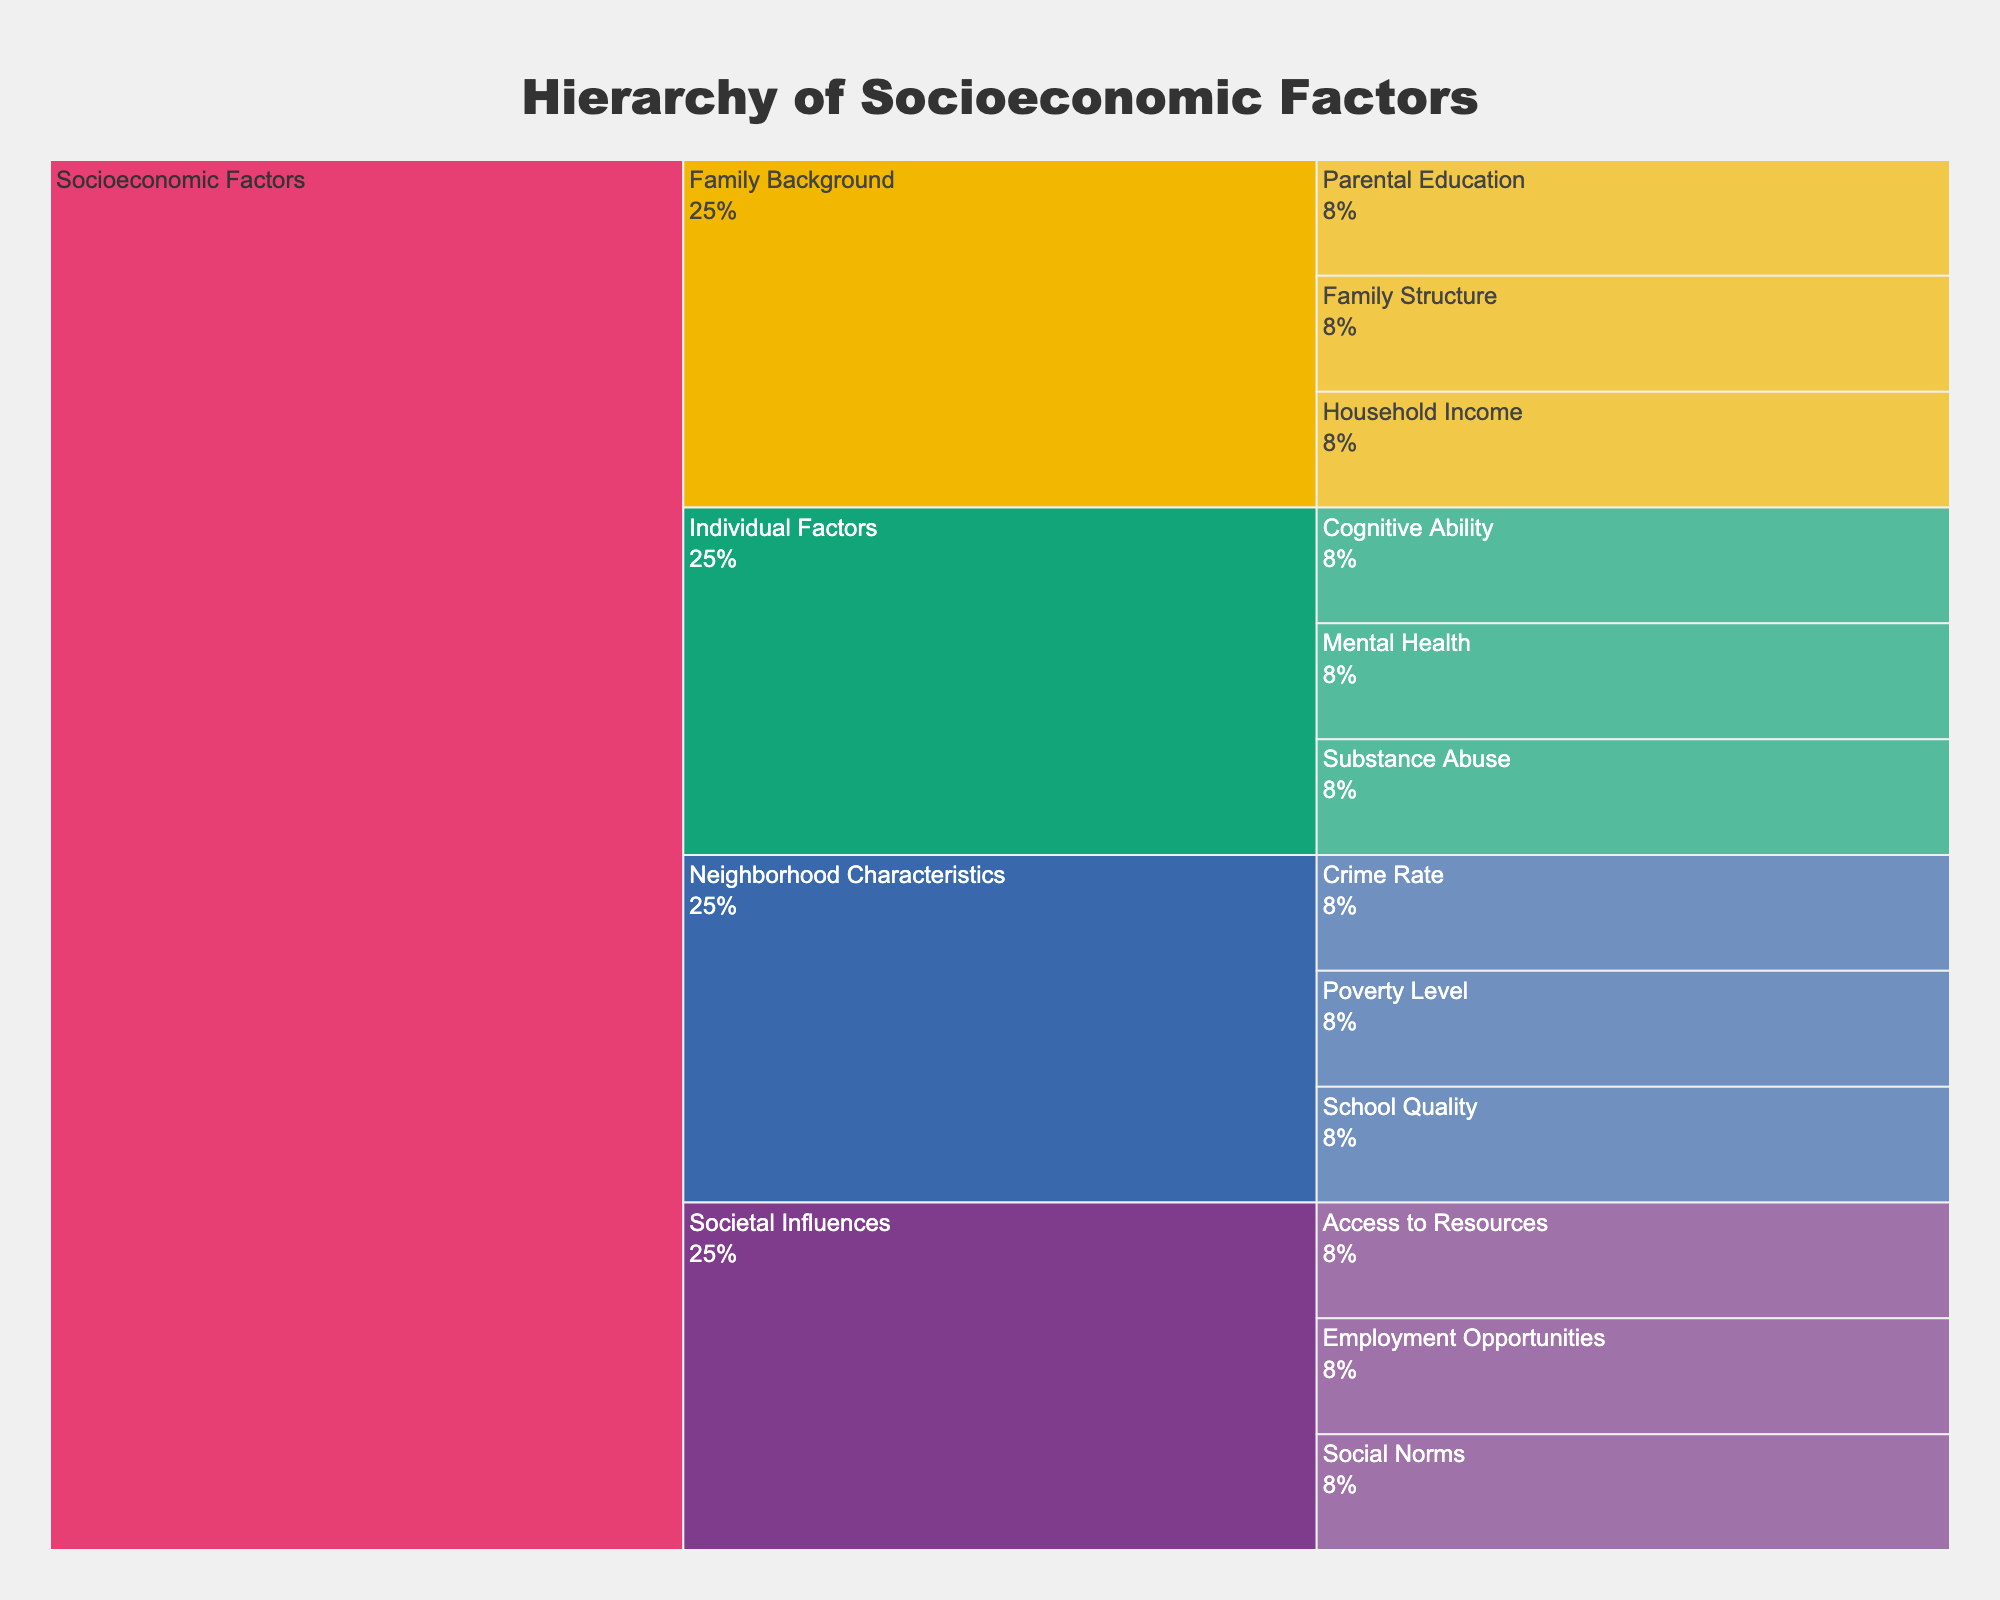What's the title of the figure? The title is located at the top center of the figure as a text element and visually distinguishes itself from other text due to its larger font size and style. It reads: "Hierarchy of Socioeconomic Factors".
Answer: Hierarchy of Socioeconomic Factors What are the main categories highlighted in different colors? In the icicle chart, the main categories are visually marked by distinct colors and include Family Background, Neighborhood Characteristics, Individual Factors, and Societal Influences.
Answer: Family Background, Neighborhood Characteristics, Individual Factors, Societal Influences Which main category includes the factor "Parental Education"? By following the hierarchy starting from the root "Socioeconomic Factors" down to the subcategory level, "Parental Education" can be found under the main category "Family Background".
Answer: Family Background How many factors are associated with "Societal Influences"? The number of factors under "Societal Influences" can be determined by counting the leaf nodes in this specific path within the hierarchy. There are three factors: Employment Opportunities, Social Norms, and Access to Resources.
Answer: 3 Which has more factors: "Family Background" or "Individual Factors"? By counting the factors listed under each category in the figure, "Family Background" has three factors, whereas "Individual Factors" also has three factors. Thus, they have an equal number of factors.
Answer: Equal Which category has the highest number of subcategories? The number of subcategories can be observed directly by examining the branches stemming from each main category. Both "Family Background" and "Neighborhood Characteristics" have two subcategories, while "Individual Factors" and "Societal Influences" don't have any. Therefore, "Family Background" or "Neighborhood Characteristics" have the highest number.
Answer: Family Background, Neighborhood Characteristics What percentage of the total entries is represented by "Individual Factors"? The percentage of the total entries for "Individual Factors" is visible by examining the text info on the corresponding segment. It's labeled with its percentage share of the total.
Answer: Percentage varies depending on the figure Is "School Quality" more related to "Family Background" or "Neighborhood Characteristics"? By following the hierarchical structure in the icicle chart, "School Quality" is categorized under "Neighborhood Characteristics" and not related to "Family Background".
Answer: Neighborhood Characteristics Which factors fall under "Neighborhood Characteristics" and how do they compare in number to "Societal Influences"? By examining the segments under "Neighborhood Characteristics", the factors are counted as Crime Rate, Poverty Level, and School Quality. "Societal Influences" also has three factors: Employment Opportunities, Social Norms, and Access to Resources, making their counts equal.
Answer: Equal 